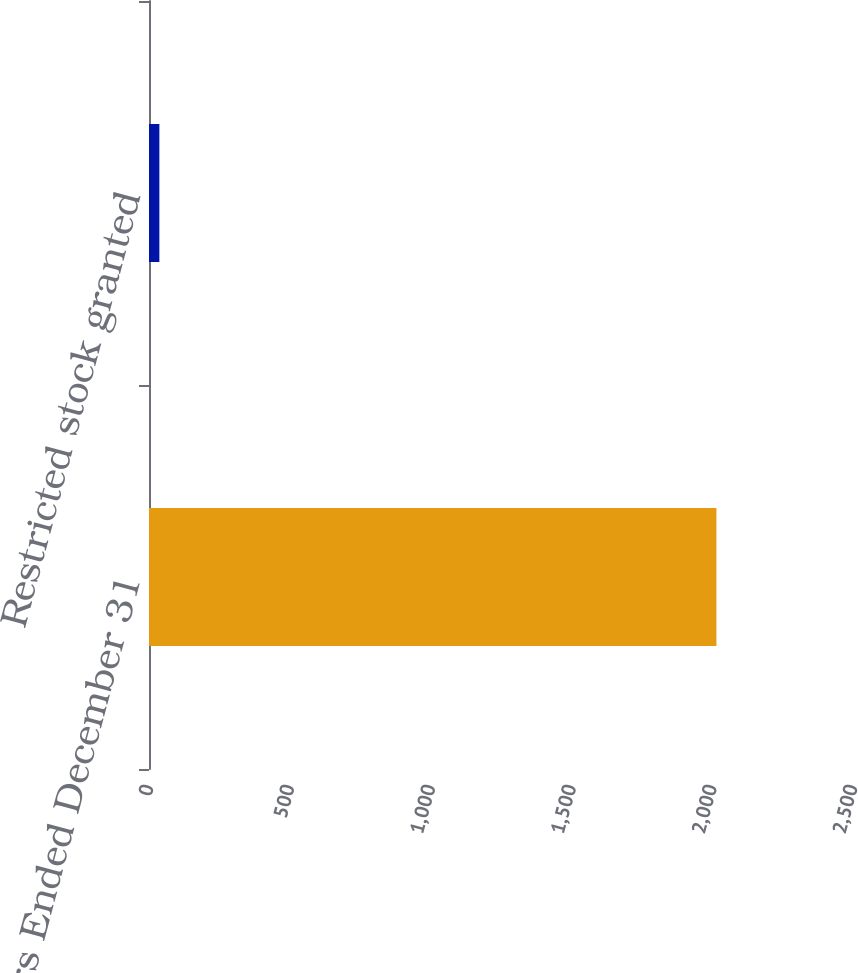Convert chart. <chart><loc_0><loc_0><loc_500><loc_500><bar_chart><fcel>Years Ended December 31<fcel>Restricted stock granted<nl><fcel>2015<fcel>36.84<nl></chart> 